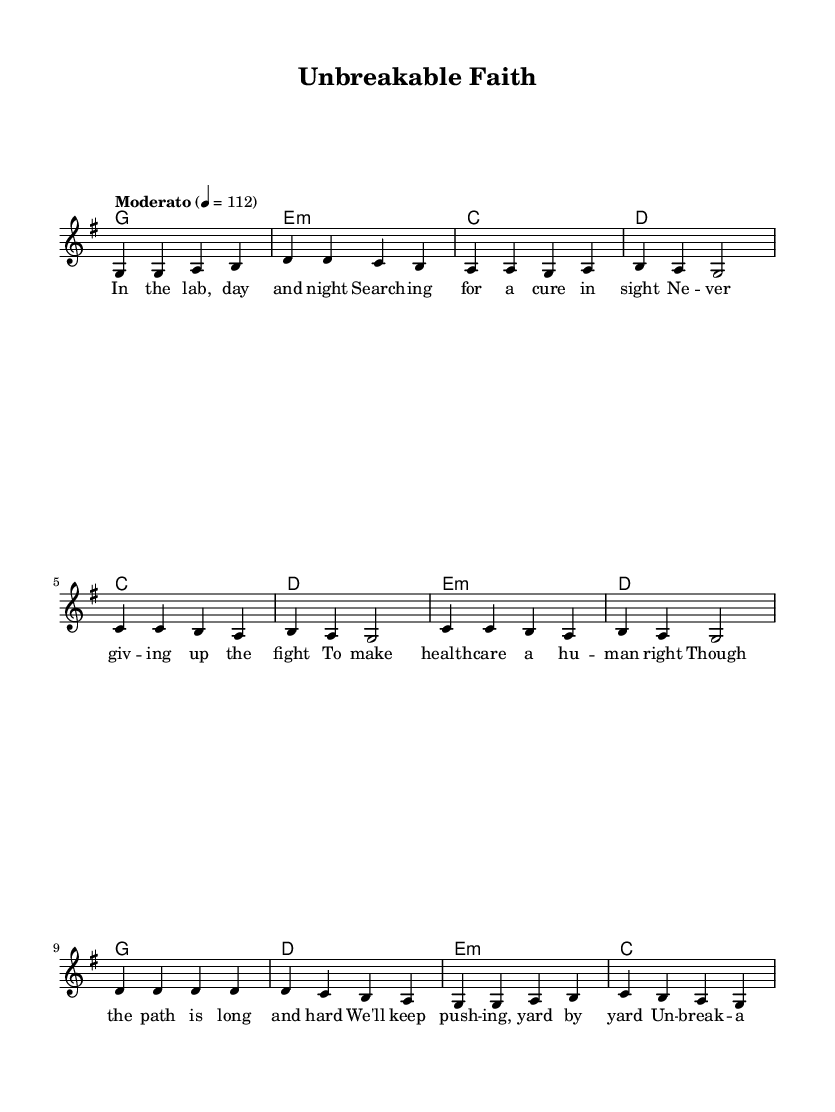What is the key signature of this music? The key signature is G major, which has one sharp (F#). This is indicated at the beginning of the score.
Answer: G major What is the time signature of this music? The time signature is 4/4, which means there are four beats in each measure and the quarter note gets one beat. This is specified at the start of the score.
Answer: 4/4 What is the tempo of this piece? The tempo is marked as Moderato, with a metronome marking of 112 beats per minute. This indicates a moderate pace for the song.
Answer: Moderato, 112 How many measures are in the chorus? The chorus consists of four measures, as indicated by the grouping of notes and the structure of the lyrics underneath.
Answer: Four measures What is the main theme expressed in the chorus lyrics? The main theme expressed in the chorus is "unbreakable faith" and "dedication," reflecting perseverance and strong commitment. This can be derived from the specific words used in the lyrics of the chorus.
Answer: Unbreakable faith, dedication How does the pre-chorus transition from the verse? The pre-chorus transitions from the verse by moving to a slightly different melodic contour and a new lyrical focus, emphasizing the challenges of the path ahead. This can be understood by comparing the melody and lyrics of the verse and pre-chorus sections.
Answer: New lyrical focus, different melodic contour What emotion do the lyrics convey throughout the piece? The lyrics convey a sense of hope and determination, emphasizing unwavering commitment despite difficulties, which is a common emotional theme in inspirational Christian music. This is reflected in both the lyrics and their context.
Answer: Hope and determination 